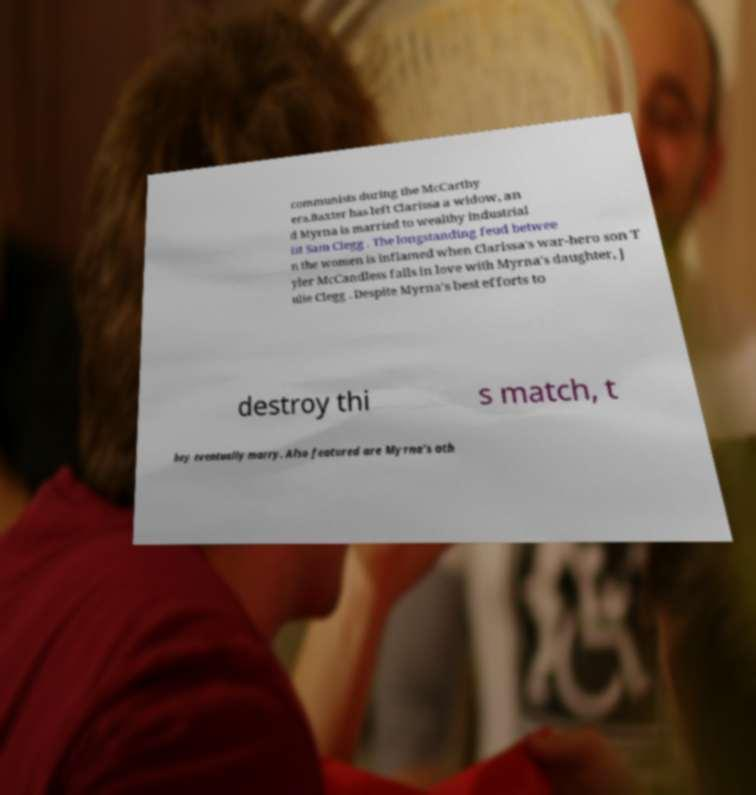Can you read and provide the text displayed in the image?This photo seems to have some interesting text. Can you extract and type it out for me? communists during the McCarthy era.Baxter has left Clarissa a widow, an d Myrna is married to wealthy industrial ist Sam Clegg . The longstanding feud betwee n the women is inflamed when Clarissa's war-hero son T yler McCandless falls in love with Myrna's daughter, J ulie Clegg . Despite Myrna's best efforts to destroy thi s match, t hey eventually marry. Also featured are Myrna's oth 